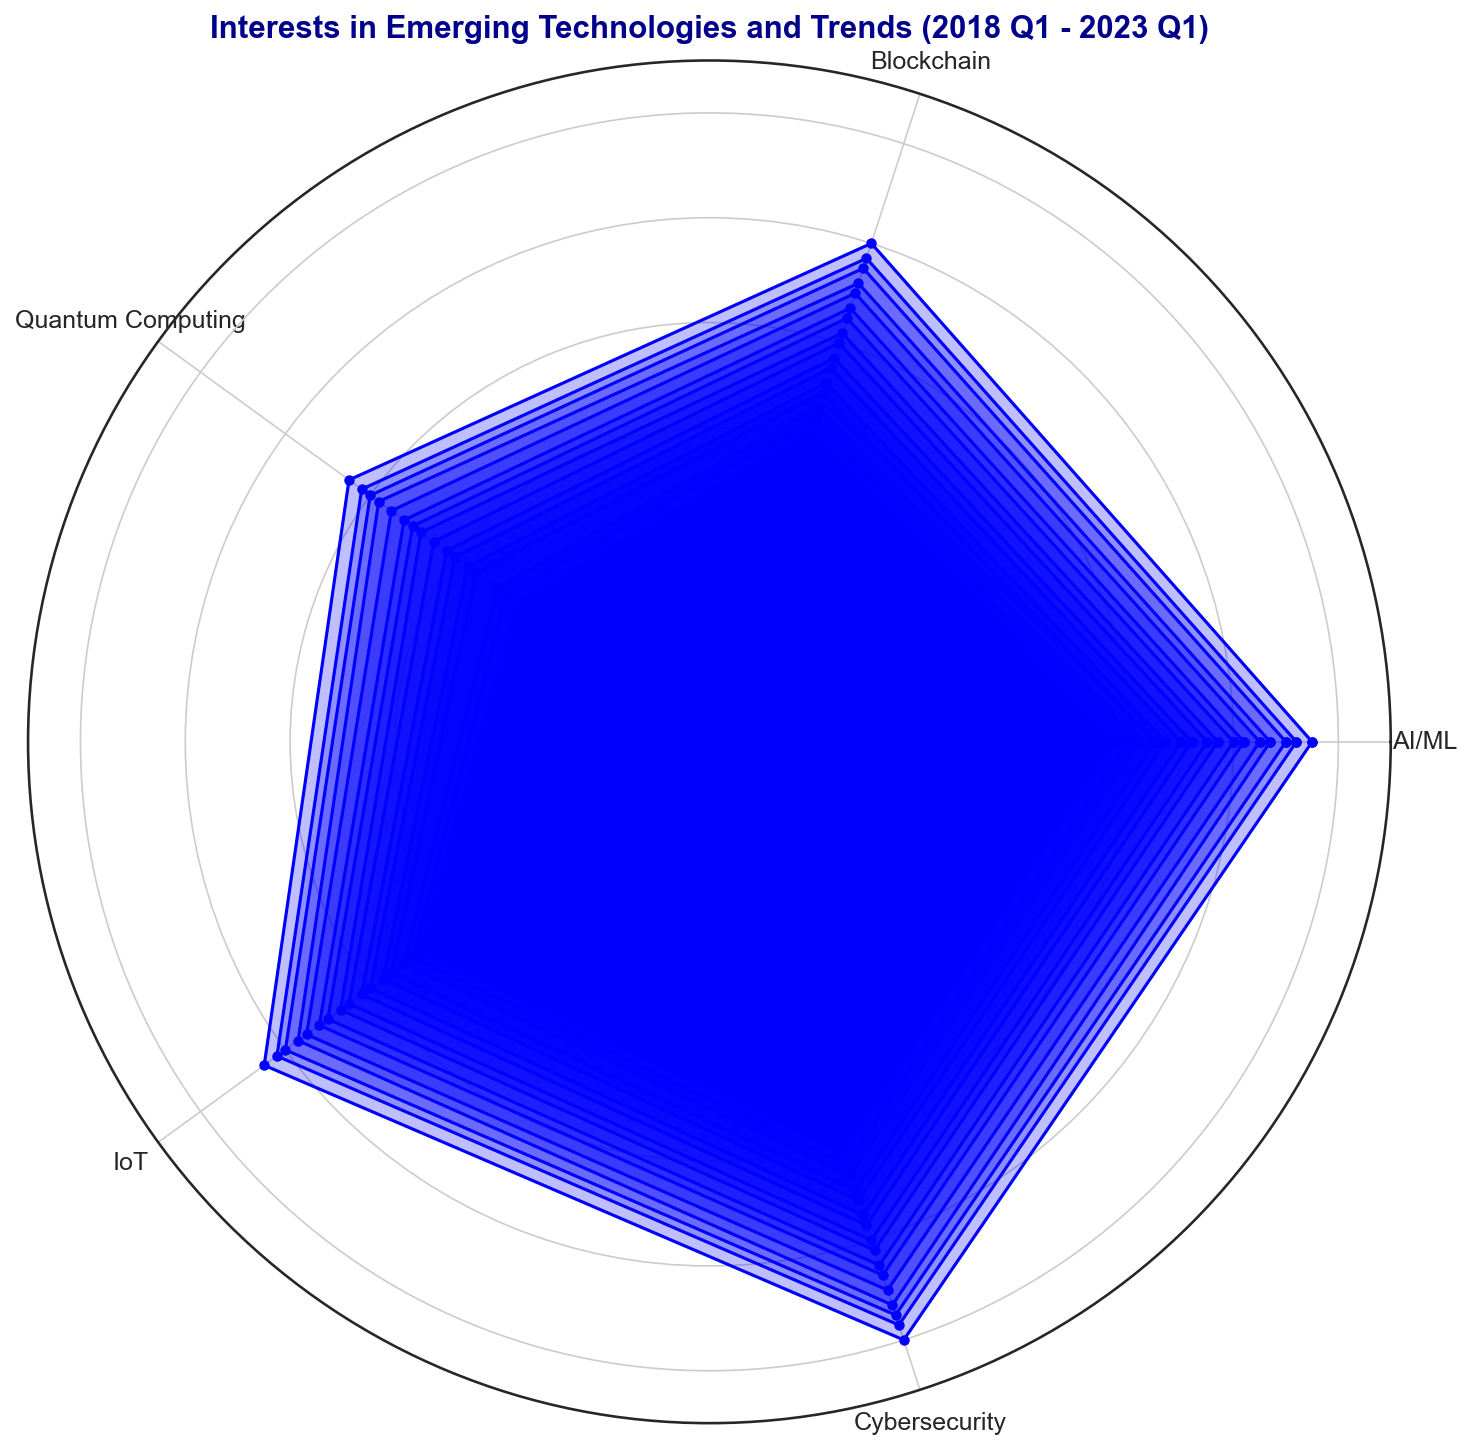What's the trend in interest in AI/ML from 2018 Q1 to 2023 Q1? The interest in AI/ML increases steadily over the entire period, starting from 65 in 2018 Q1 and reaching 115 in 2023 Q1. This shows a continuous upward trend every quarter.
Answer: Steady increase Between 2020 Q1 and 2021 Q1, which technology saw the highest increase in interest? Interest in AI/ML increased from 85 in 2020 Q1 to 95 in 2021 Q1, which is a difference of 10. Blockchain increased from 70 to 80, a difference of 10. Quantum Computing increased from 55 to 65, a difference of 10. IoT increased from 75 to 85, a difference of 10. Cybersecurity increased from 90 to 100, a difference of 10. All technologies saw an equal increase in interest.
Answer: All equally How does the interest in Quantum Computing in 2021 Q3 compare to that in IoT in the same quarter? In 2021 Q3, the interest in Quantum Computing is at 70, while the interest in IoT is at 90. Hence, the interest in IoT is higher than in Quantum Computing by 20 points.
Answer: IoT is higher by 20 Which technology had the most significant increase in interest from 2018 Q1 to 2023 Q1? The interest in AI/ML increased from 65 to 115, a difference of 50. Blockchain increased from 50 to 100, a difference of 50. Quantum Computing increased from 30 to 85, a difference of 55. IoT increased from 60 to 105, a difference of 45. Cybersecurity increased from 70 to 120, a difference of 50. Thus, Quantum Computing had the most significant increase.
Answer: Quantum Computing What's the combined interest in AI/ML and Cybersecurity in 2023 Q1? In 2023 Q1, the interest in AI/ML is 115, and the interest in Cybersecurity is 120. The combined interest is 115 + 120 = 235.
Answer: 235 During which quarter did interest in IoT surpass 80 for the first time? The interest in IoT surpassed 80 in 2020 Q3 when it reached 82.
Answer: 2020 Q3 Is the interest in Blockchain always below that of AI/ML in the given period? By comparing the interest values in each quarter, we see that Blockchain values are always less than AI/ML values throughout the entire period from 2018 Q1 to 2023 Q1. Thus, Blockchain interest is always below that of AI/ML.
Answer: Yes Which quarter shows the highest interest in Cybersecurity? The quarter with the highest interest in Cybersecurity is 2023 Q1, with an interest value of 120.
Answer: 2023 Q1 